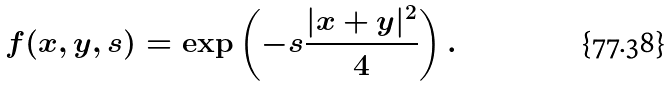Convert formula to latex. <formula><loc_0><loc_0><loc_500><loc_500>f ( x , y , s ) = \exp \left ( - s \frac { | x + y | ^ { 2 } } 4 \right ) .</formula> 